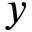<formula> <loc_0><loc_0><loc_500><loc_500>y</formula> 